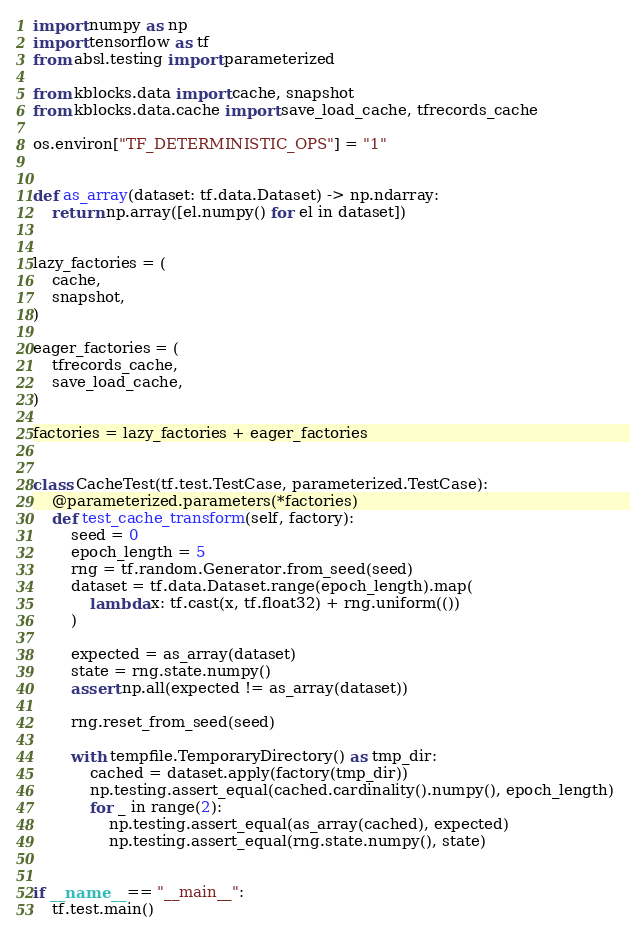Convert code to text. <code><loc_0><loc_0><loc_500><loc_500><_Python_>
import numpy as np
import tensorflow as tf
from absl.testing import parameterized

from kblocks.data import cache, snapshot
from kblocks.data.cache import save_load_cache, tfrecords_cache

os.environ["TF_DETERMINISTIC_OPS"] = "1"


def as_array(dataset: tf.data.Dataset) -> np.ndarray:
    return np.array([el.numpy() for el in dataset])


lazy_factories = (
    cache,
    snapshot,
)

eager_factories = (
    tfrecords_cache,
    save_load_cache,
)

factories = lazy_factories + eager_factories


class CacheTest(tf.test.TestCase, parameterized.TestCase):
    @parameterized.parameters(*factories)
    def test_cache_transform(self, factory):
        seed = 0
        epoch_length = 5
        rng = tf.random.Generator.from_seed(seed)
        dataset = tf.data.Dataset.range(epoch_length).map(
            lambda x: tf.cast(x, tf.float32) + rng.uniform(())
        )

        expected = as_array(dataset)
        state = rng.state.numpy()
        assert np.all(expected != as_array(dataset))

        rng.reset_from_seed(seed)

        with tempfile.TemporaryDirectory() as tmp_dir:
            cached = dataset.apply(factory(tmp_dir))
            np.testing.assert_equal(cached.cardinality().numpy(), epoch_length)
            for _ in range(2):
                np.testing.assert_equal(as_array(cached), expected)
                np.testing.assert_equal(rng.state.numpy(), state)


if __name__ == "__main__":
    tf.test.main()
</code> 